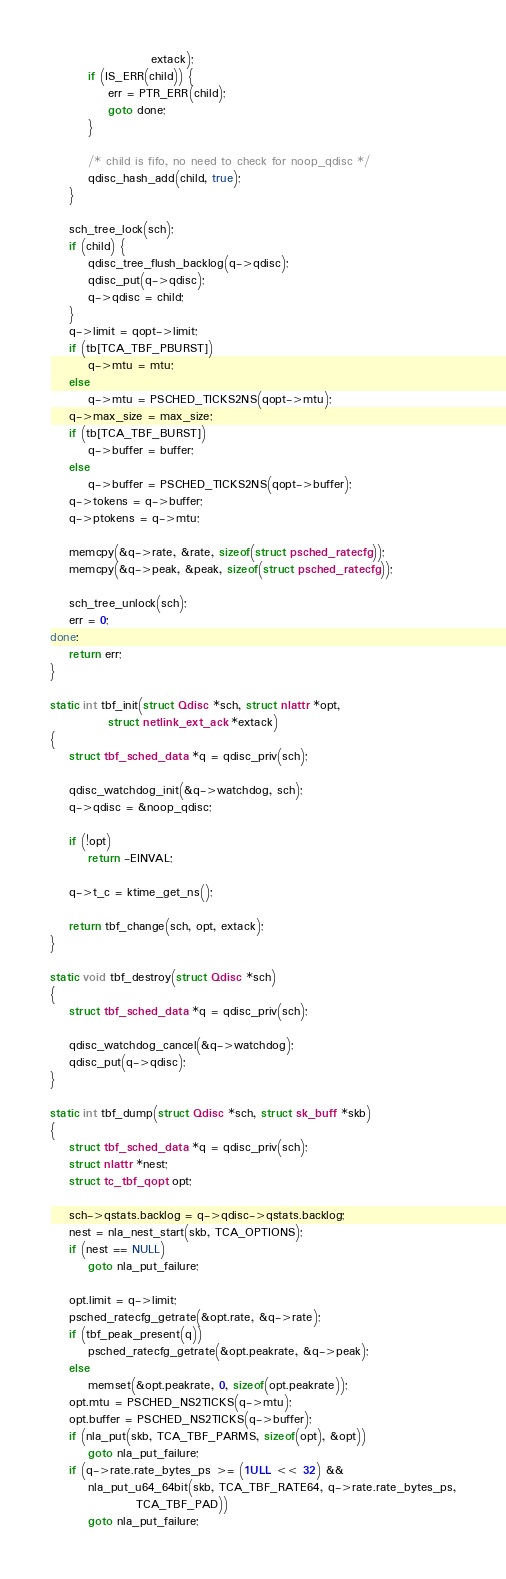Convert code to text. <code><loc_0><loc_0><loc_500><loc_500><_C_>					 extack);
		if (IS_ERR(child)) {
			err = PTR_ERR(child);
			goto done;
		}

		/* child is fifo, no need to check for noop_qdisc */
		qdisc_hash_add(child, true);
	}

	sch_tree_lock(sch);
	if (child) {
		qdisc_tree_flush_backlog(q->qdisc);
		qdisc_put(q->qdisc);
		q->qdisc = child;
	}
	q->limit = qopt->limit;
	if (tb[TCA_TBF_PBURST])
		q->mtu = mtu;
	else
		q->mtu = PSCHED_TICKS2NS(qopt->mtu);
	q->max_size = max_size;
	if (tb[TCA_TBF_BURST])
		q->buffer = buffer;
	else
		q->buffer = PSCHED_TICKS2NS(qopt->buffer);
	q->tokens = q->buffer;
	q->ptokens = q->mtu;

	memcpy(&q->rate, &rate, sizeof(struct psched_ratecfg));
	memcpy(&q->peak, &peak, sizeof(struct psched_ratecfg));

	sch_tree_unlock(sch);
	err = 0;
done:
	return err;
}

static int tbf_init(struct Qdisc *sch, struct nlattr *opt,
		    struct netlink_ext_ack *extack)
{
	struct tbf_sched_data *q = qdisc_priv(sch);

	qdisc_watchdog_init(&q->watchdog, sch);
	q->qdisc = &noop_qdisc;

	if (!opt)
		return -EINVAL;

	q->t_c = ktime_get_ns();

	return tbf_change(sch, opt, extack);
}

static void tbf_destroy(struct Qdisc *sch)
{
	struct tbf_sched_data *q = qdisc_priv(sch);

	qdisc_watchdog_cancel(&q->watchdog);
	qdisc_put(q->qdisc);
}

static int tbf_dump(struct Qdisc *sch, struct sk_buff *skb)
{
	struct tbf_sched_data *q = qdisc_priv(sch);
	struct nlattr *nest;
	struct tc_tbf_qopt opt;

	sch->qstats.backlog = q->qdisc->qstats.backlog;
	nest = nla_nest_start(skb, TCA_OPTIONS);
	if (nest == NULL)
		goto nla_put_failure;

	opt.limit = q->limit;
	psched_ratecfg_getrate(&opt.rate, &q->rate);
	if (tbf_peak_present(q))
		psched_ratecfg_getrate(&opt.peakrate, &q->peak);
	else
		memset(&opt.peakrate, 0, sizeof(opt.peakrate));
	opt.mtu = PSCHED_NS2TICKS(q->mtu);
	opt.buffer = PSCHED_NS2TICKS(q->buffer);
	if (nla_put(skb, TCA_TBF_PARMS, sizeof(opt), &opt))
		goto nla_put_failure;
	if (q->rate.rate_bytes_ps >= (1ULL << 32) &&
	    nla_put_u64_64bit(skb, TCA_TBF_RATE64, q->rate.rate_bytes_ps,
			      TCA_TBF_PAD))
		goto nla_put_failure;</code> 